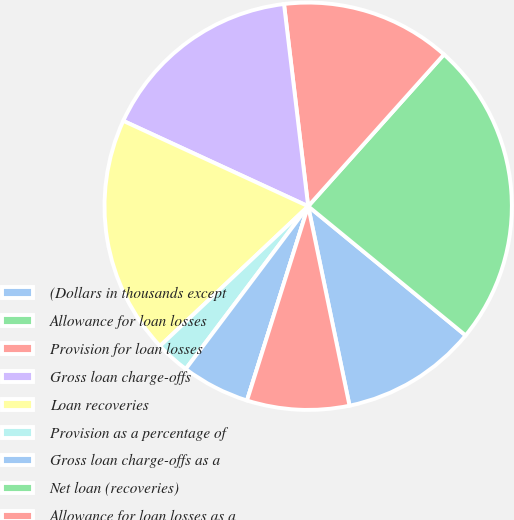<chart> <loc_0><loc_0><loc_500><loc_500><pie_chart><fcel>(Dollars in thousands except<fcel>Allowance for loan losses<fcel>Provision for loan losses<fcel>Gross loan charge-offs<fcel>Loan recoveries<fcel>Provision as a percentage of<fcel>Gross loan charge-offs as a<fcel>Net loan (recoveries)<fcel>Allowance for loan losses as a<nl><fcel>10.81%<fcel>24.32%<fcel>13.51%<fcel>16.22%<fcel>18.92%<fcel>2.7%<fcel>5.41%<fcel>0.0%<fcel>8.11%<nl></chart> 